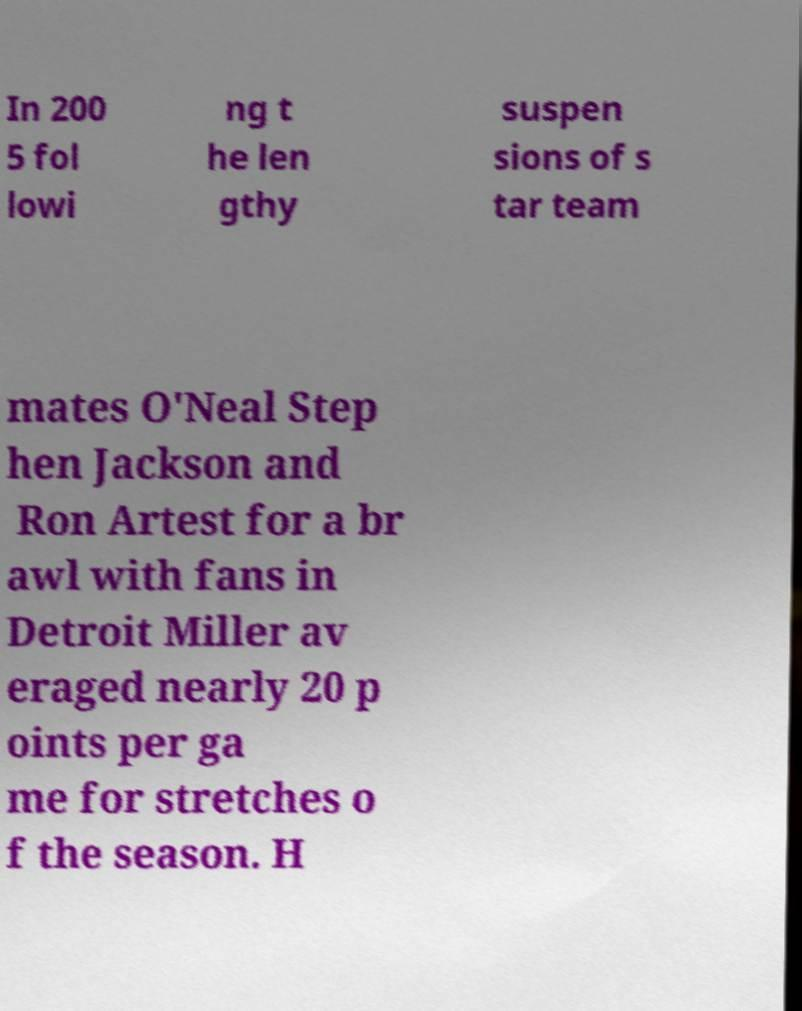What messages or text are displayed in this image? I need them in a readable, typed format. In 200 5 fol lowi ng t he len gthy suspen sions of s tar team mates O'Neal Step hen Jackson and Ron Artest for a br awl with fans in Detroit Miller av eraged nearly 20 p oints per ga me for stretches o f the season. H 